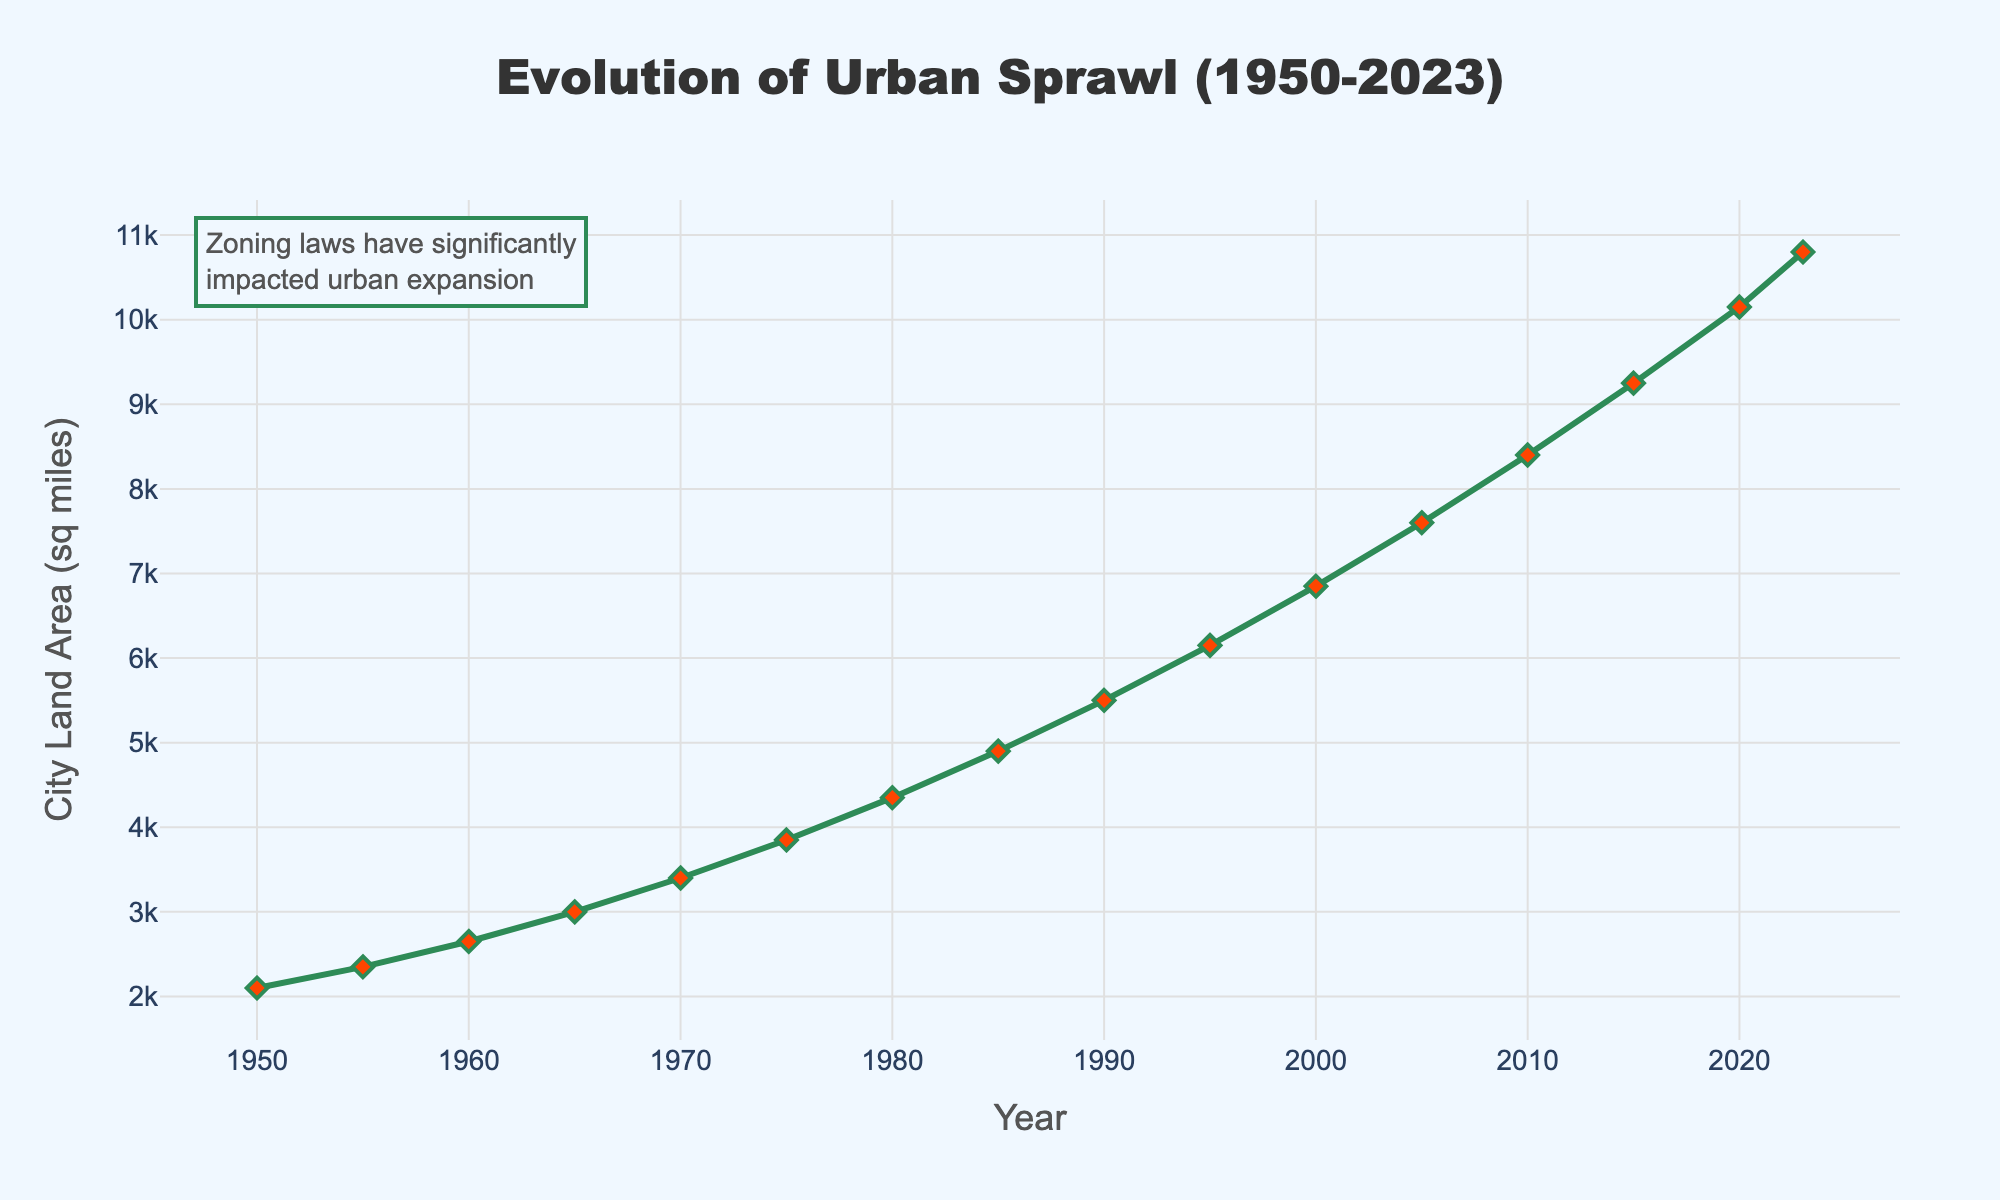What is the total urban sprawl in square miles by 2020? According to the line chart, the urban sprawl in 2020 is approximately 10150 square miles.
Answer: 10150 How much did the urban sprawl increase between 1950 and 1980? The urban sprawl in 1950 was 2100 square miles, and it increased to 4350 square miles by 1980. The increase is calculated by subtracting 2100 from 4350.
Answer: 2250 In which year did the urban sprawl exceed 5000 square miles? From the chart, it can be seen that the urban sprawl exceeded 5000 square miles in 1985.
Answer: 1985 What is the difference in urban sprawl between 1990 and 2023? The urban sprawl in 1990 is 5500 square miles, and in 2023 it is 10800 square miles. The difference is 10800 minus 5500.
Answer: 5300 How many square miles did the urban sprawl expand between 2005 and 2015? The urban sprawl was 7600 square miles in 2005 and increased to 9250 square miles by 2015. The expansion is 9250 minus 7600.
Answer: 1650 Between which consecutive years was the largest increase in urban sprawl observed? By examining the chart, the largest increase is observed between 2015 and 2020, where the change is from 9250 to 10150 square miles.
Answer: 2015 to 2020 Compare the growth in urban sprawl from 1950 to 1970 and from 2000 to 2020. From 1950 to 1970, the urban sprawl increased from 2100 to 3400 square miles, a difference of 1300. From 2000 to 2020, it increased from 6850 to 10150 square miles, a difference of 3300.
Answer: 2000 to 2020 What is the average urban sprawl from 1950 to 1990? To find the average, first sum the values from 1950 (2100), 1955 (2350), 1960 (2650), 1965 (3000), 1970 (3400), 1975 (3850), 1980 (4350), and 1985 (4900) to 1990 (5500) and divide by the number of entries. (2100 + 2350 + 2650 + 3000 + 3400 + 3850 + 4350 + 4900 + 5500 = 32100) divided by 9.
Answer: 3566.67 